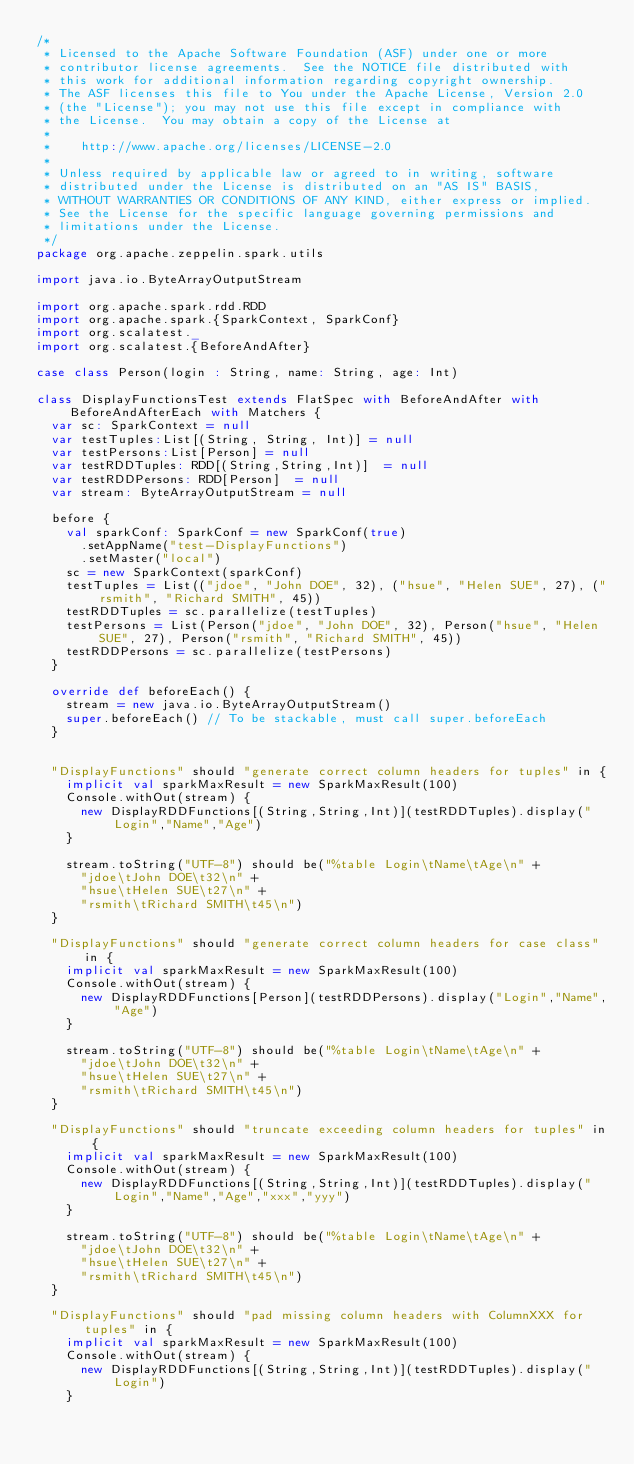<code> <loc_0><loc_0><loc_500><loc_500><_Scala_>/*
 * Licensed to the Apache Software Foundation (ASF) under one or more
 * contributor license agreements.  See the NOTICE file distributed with
 * this work for additional information regarding copyright ownership.
 * The ASF licenses this file to You under the Apache License, Version 2.0
 * (the "License"); you may not use this file except in compliance with
 * the License.  You may obtain a copy of the License at
 *
 *    http://www.apache.org/licenses/LICENSE-2.0
 *
 * Unless required by applicable law or agreed to in writing, software
 * distributed under the License is distributed on an "AS IS" BASIS,
 * WITHOUT WARRANTIES OR CONDITIONS OF ANY KIND, either express or implied.
 * See the License for the specific language governing permissions and
 * limitations under the License.
 */
package org.apache.zeppelin.spark.utils

import java.io.ByteArrayOutputStream

import org.apache.spark.rdd.RDD
import org.apache.spark.{SparkContext, SparkConf}
import org.scalatest._
import org.scalatest.{BeforeAndAfter}

case class Person(login : String, name: String, age: Int)

class DisplayFunctionsTest extends FlatSpec with BeforeAndAfter with BeforeAndAfterEach with Matchers {
  var sc: SparkContext = null
  var testTuples:List[(String, String, Int)] = null
  var testPersons:List[Person] = null
  var testRDDTuples: RDD[(String,String,Int)]  = null
  var testRDDPersons: RDD[Person]  = null
  var stream: ByteArrayOutputStream = null
  
  before {
    val sparkConf: SparkConf = new SparkConf(true)
      .setAppName("test-DisplayFunctions")
      .setMaster("local")
    sc = new SparkContext(sparkConf)
    testTuples = List(("jdoe", "John DOE", 32), ("hsue", "Helen SUE", 27), ("rsmith", "Richard SMITH", 45))
    testRDDTuples = sc.parallelize(testTuples)
    testPersons = List(Person("jdoe", "John DOE", 32), Person("hsue", "Helen SUE", 27), Person("rsmith", "Richard SMITH", 45))
    testRDDPersons = sc.parallelize(testPersons)
  }

  override def beforeEach() {
    stream = new java.io.ByteArrayOutputStream()
    super.beforeEach() // To be stackable, must call super.beforeEach
  }


  "DisplayFunctions" should "generate correct column headers for tuples" in {
    implicit val sparkMaxResult = new SparkMaxResult(100)
    Console.withOut(stream) {
      new DisplayRDDFunctions[(String,String,Int)](testRDDTuples).display("Login","Name","Age")
    }

    stream.toString("UTF-8") should be("%table Login\tName\tAge\n" +
      "jdoe\tJohn DOE\t32\n" +
      "hsue\tHelen SUE\t27\n" +
      "rsmith\tRichard SMITH\t45\n")
  }

  "DisplayFunctions" should "generate correct column headers for case class" in {
    implicit val sparkMaxResult = new SparkMaxResult(100)
    Console.withOut(stream) {
      new DisplayRDDFunctions[Person](testRDDPersons).display("Login","Name","Age")
    }

    stream.toString("UTF-8") should be("%table Login\tName\tAge\n" +
      "jdoe\tJohn DOE\t32\n" +
      "hsue\tHelen SUE\t27\n" +
      "rsmith\tRichard SMITH\t45\n")
  }

  "DisplayFunctions" should "truncate exceeding column headers for tuples" in {
    implicit val sparkMaxResult = new SparkMaxResult(100)
    Console.withOut(stream) {
      new DisplayRDDFunctions[(String,String,Int)](testRDDTuples).display("Login","Name","Age","xxx","yyy")
    }

    stream.toString("UTF-8") should be("%table Login\tName\tAge\n" +
      "jdoe\tJohn DOE\t32\n" +
      "hsue\tHelen SUE\t27\n" +
      "rsmith\tRichard SMITH\t45\n")
  }

  "DisplayFunctions" should "pad missing column headers with ColumnXXX for tuples" in {
    implicit val sparkMaxResult = new SparkMaxResult(100)
    Console.withOut(stream) {
      new DisplayRDDFunctions[(String,String,Int)](testRDDTuples).display("Login")
    }
</code> 